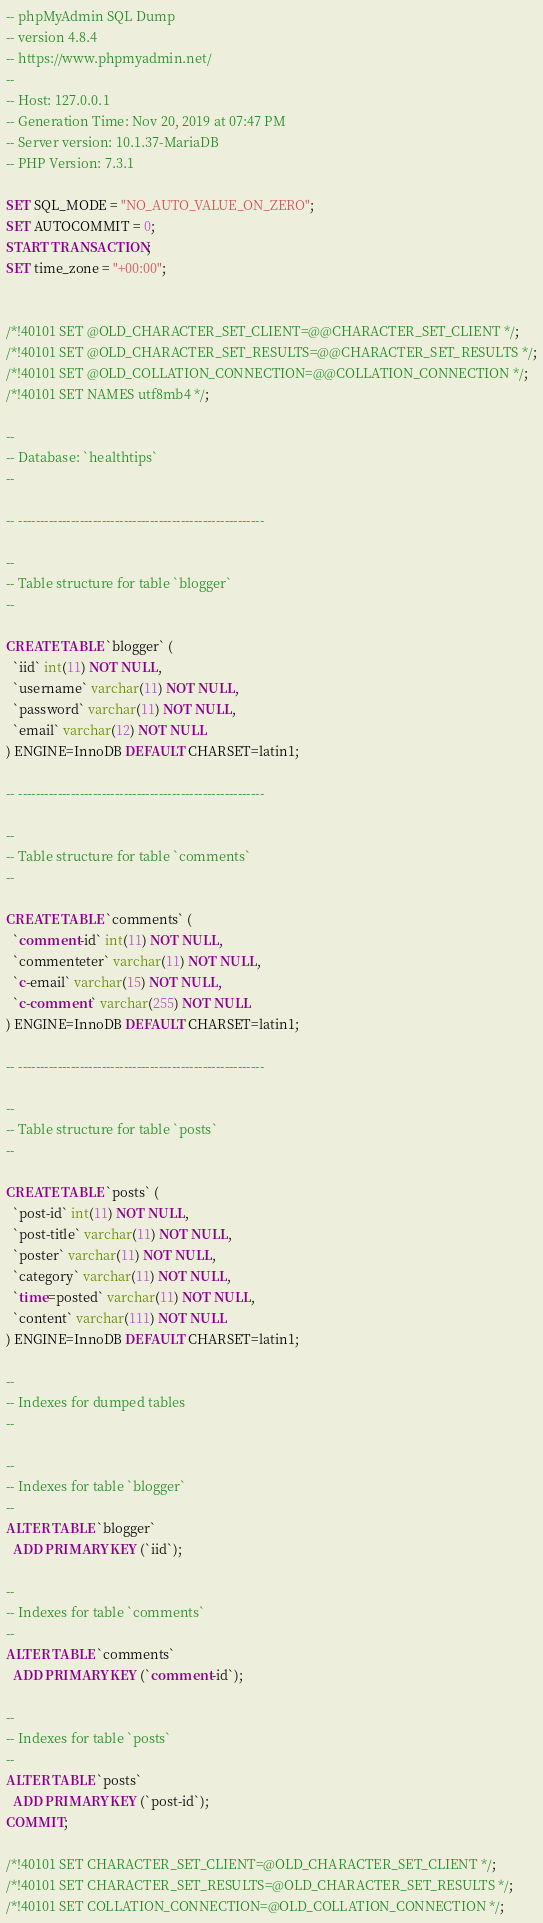Convert code to text. <code><loc_0><loc_0><loc_500><loc_500><_SQL_>-- phpMyAdmin SQL Dump
-- version 4.8.4
-- https://www.phpmyadmin.net/
--
-- Host: 127.0.0.1
-- Generation Time: Nov 20, 2019 at 07:47 PM
-- Server version: 10.1.37-MariaDB
-- PHP Version: 7.3.1

SET SQL_MODE = "NO_AUTO_VALUE_ON_ZERO";
SET AUTOCOMMIT = 0;
START TRANSACTION;
SET time_zone = "+00:00";


/*!40101 SET @OLD_CHARACTER_SET_CLIENT=@@CHARACTER_SET_CLIENT */;
/*!40101 SET @OLD_CHARACTER_SET_RESULTS=@@CHARACTER_SET_RESULTS */;
/*!40101 SET @OLD_COLLATION_CONNECTION=@@COLLATION_CONNECTION */;
/*!40101 SET NAMES utf8mb4 */;

--
-- Database: `healthtips`
--

-- --------------------------------------------------------

--
-- Table structure for table `blogger`
--

CREATE TABLE `blogger` (
  `iid` int(11) NOT NULL,
  `username` varchar(11) NOT NULL,
  `password` varchar(11) NOT NULL,
  `email` varchar(12) NOT NULL
) ENGINE=InnoDB DEFAULT CHARSET=latin1;

-- --------------------------------------------------------

--
-- Table structure for table `comments`
--

CREATE TABLE `comments` (
  `comment-id` int(11) NOT NULL,
  `commenteter` varchar(11) NOT NULL,
  `c-email` varchar(15) NOT NULL,
  `c-comment` varchar(255) NOT NULL
) ENGINE=InnoDB DEFAULT CHARSET=latin1;

-- --------------------------------------------------------

--
-- Table structure for table `posts`
--

CREATE TABLE `posts` (
  `post-id` int(11) NOT NULL,
  `post-title` varchar(11) NOT NULL,
  `poster` varchar(11) NOT NULL,
  `category` varchar(11) NOT NULL,
  `time=posted` varchar(11) NOT NULL,
  `content` varchar(111) NOT NULL
) ENGINE=InnoDB DEFAULT CHARSET=latin1;

--
-- Indexes for dumped tables
--

--
-- Indexes for table `blogger`
--
ALTER TABLE `blogger`
  ADD PRIMARY KEY (`iid`);

--
-- Indexes for table `comments`
--
ALTER TABLE `comments`
  ADD PRIMARY KEY (`comment-id`);

--
-- Indexes for table `posts`
--
ALTER TABLE `posts`
  ADD PRIMARY KEY (`post-id`);
COMMIT;

/*!40101 SET CHARACTER_SET_CLIENT=@OLD_CHARACTER_SET_CLIENT */;
/*!40101 SET CHARACTER_SET_RESULTS=@OLD_CHARACTER_SET_RESULTS */;
/*!40101 SET COLLATION_CONNECTION=@OLD_COLLATION_CONNECTION */;
</code> 